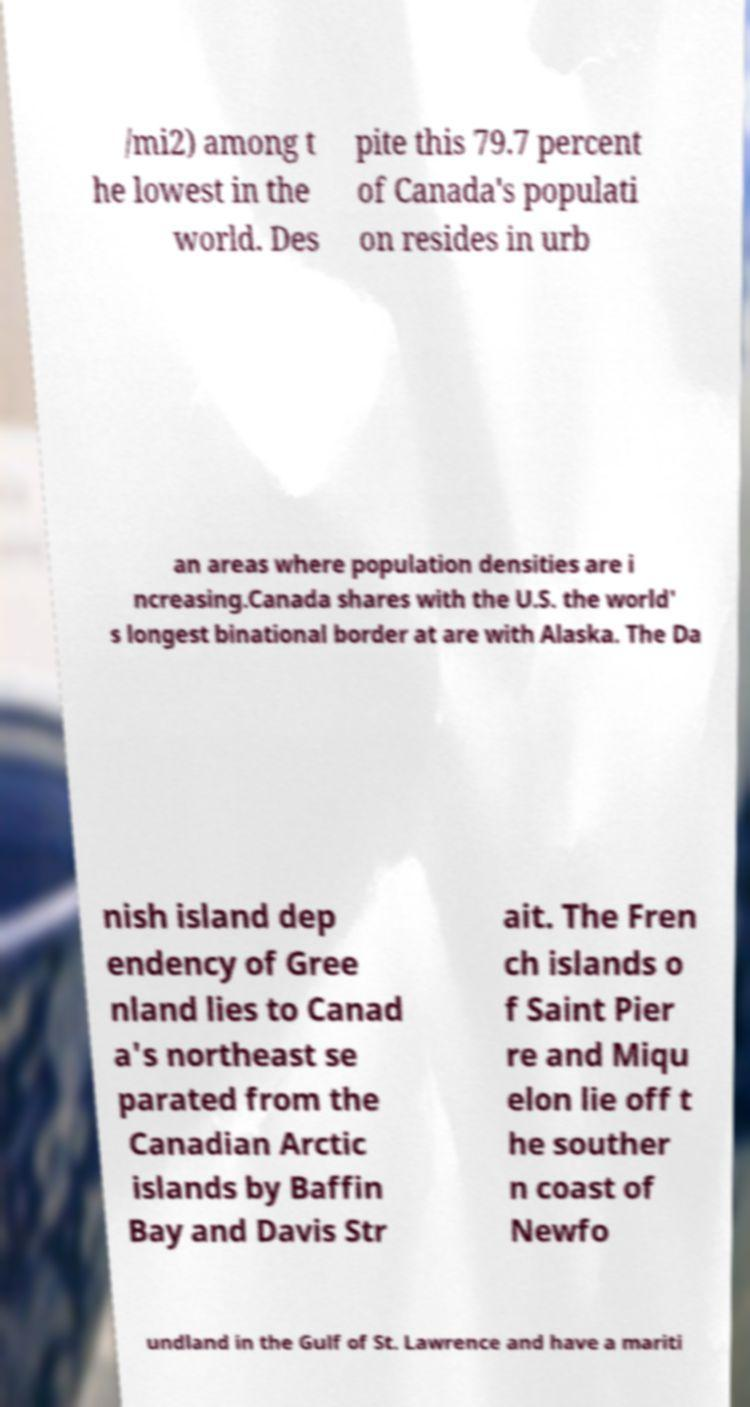There's text embedded in this image that I need extracted. Can you transcribe it verbatim? /mi2) among t he lowest in the world. Des pite this 79.7 percent of Canada's populati on resides in urb an areas where population densities are i ncreasing.Canada shares with the U.S. the world' s longest binational border at are with Alaska. The Da nish island dep endency of Gree nland lies to Canad a's northeast se parated from the Canadian Arctic islands by Baffin Bay and Davis Str ait. The Fren ch islands o f Saint Pier re and Miqu elon lie off t he souther n coast of Newfo undland in the Gulf of St. Lawrence and have a mariti 